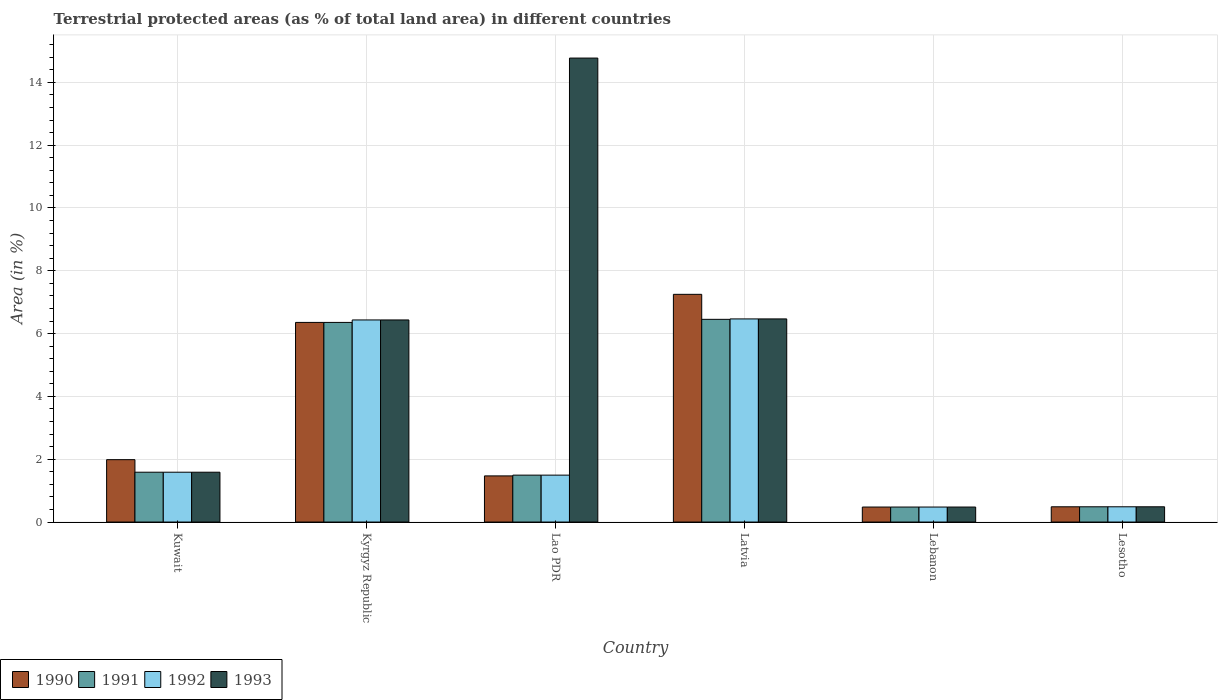How many different coloured bars are there?
Provide a short and direct response. 4. How many bars are there on the 4th tick from the right?
Your answer should be compact. 4. What is the label of the 1st group of bars from the left?
Make the answer very short. Kuwait. In how many cases, is the number of bars for a given country not equal to the number of legend labels?
Your answer should be compact. 0. What is the percentage of terrestrial protected land in 1990 in Lao PDR?
Provide a succinct answer. 1.47. Across all countries, what is the maximum percentage of terrestrial protected land in 1992?
Your response must be concise. 6.47. Across all countries, what is the minimum percentage of terrestrial protected land in 1992?
Ensure brevity in your answer.  0.48. In which country was the percentage of terrestrial protected land in 1993 maximum?
Provide a succinct answer. Lao PDR. In which country was the percentage of terrestrial protected land in 1992 minimum?
Your answer should be compact. Lebanon. What is the total percentage of terrestrial protected land in 1993 in the graph?
Offer a very short reply. 30.23. What is the difference between the percentage of terrestrial protected land in 1993 in Kuwait and that in Kyrgyz Republic?
Make the answer very short. -4.85. What is the difference between the percentage of terrestrial protected land in 1993 in Lesotho and the percentage of terrestrial protected land in 1990 in Kuwait?
Your answer should be very brief. -1.5. What is the average percentage of terrestrial protected land in 1990 per country?
Your response must be concise. 3. What is the difference between the percentage of terrestrial protected land of/in 1990 and percentage of terrestrial protected land of/in 1993 in Kuwait?
Make the answer very short. 0.4. In how many countries, is the percentage of terrestrial protected land in 1992 greater than 14.4 %?
Your answer should be compact. 0. What is the ratio of the percentage of terrestrial protected land in 1990 in Latvia to that in Lebanon?
Ensure brevity in your answer.  15.19. What is the difference between the highest and the second highest percentage of terrestrial protected land in 1992?
Provide a short and direct response. -4.88. What is the difference between the highest and the lowest percentage of terrestrial protected land in 1993?
Keep it short and to the point. 14.3. In how many countries, is the percentage of terrestrial protected land in 1992 greater than the average percentage of terrestrial protected land in 1992 taken over all countries?
Your answer should be very brief. 2. Is it the case that in every country, the sum of the percentage of terrestrial protected land in 1991 and percentage of terrestrial protected land in 1993 is greater than the sum of percentage of terrestrial protected land in 1992 and percentage of terrestrial protected land in 1990?
Provide a short and direct response. No. What does the 2nd bar from the right in Lesotho represents?
Make the answer very short. 1992. Is it the case that in every country, the sum of the percentage of terrestrial protected land in 1992 and percentage of terrestrial protected land in 1993 is greater than the percentage of terrestrial protected land in 1990?
Offer a very short reply. Yes. How many bars are there?
Provide a succinct answer. 24. Are all the bars in the graph horizontal?
Make the answer very short. No. How many countries are there in the graph?
Ensure brevity in your answer.  6. Are the values on the major ticks of Y-axis written in scientific E-notation?
Ensure brevity in your answer.  No. Where does the legend appear in the graph?
Your answer should be compact. Bottom left. How are the legend labels stacked?
Offer a terse response. Horizontal. What is the title of the graph?
Provide a succinct answer. Terrestrial protected areas (as % of total land area) in different countries. What is the label or title of the X-axis?
Ensure brevity in your answer.  Country. What is the label or title of the Y-axis?
Your answer should be compact. Area (in %). What is the Area (in %) of 1990 in Kuwait?
Ensure brevity in your answer.  1.99. What is the Area (in %) of 1991 in Kuwait?
Your answer should be compact. 1.59. What is the Area (in %) in 1992 in Kuwait?
Ensure brevity in your answer.  1.59. What is the Area (in %) in 1993 in Kuwait?
Provide a succinct answer. 1.59. What is the Area (in %) of 1990 in Kyrgyz Republic?
Offer a very short reply. 6.36. What is the Area (in %) of 1991 in Kyrgyz Republic?
Ensure brevity in your answer.  6.36. What is the Area (in %) of 1992 in Kyrgyz Republic?
Offer a terse response. 6.43. What is the Area (in %) in 1993 in Kyrgyz Republic?
Your answer should be very brief. 6.43. What is the Area (in %) in 1990 in Lao PDR?
Offer a terse response. 1.47. What is the Area (in %) in 1991 in Lao PDR?
Ensure brevity in your answer.  1.49. What is the Area (in %) in 1992 in Lao PDR?
Offer a terse response. 1.49. What is the Area (in %) in 1993 in Lao PDR?
Give a very brief answer. 14.77. What is the Area (in %) in 1990 in Latvia?
Offer a very short reply. 7.25. What is the Area (in %) of 1991 in Latvia?
Keep it short and to the point. 6.45. What is the Area (in %) in 1992 in Latvia?
Provide a succinct answer. 6.47. What is the Area (in %) in 1993 in Latvia?
Keep it short and to the point. 6.47. What is the Area (in %) of 1990 in Lebanon?
Make the answer very short. 0.48. What is the Area (in %) in 1991 in Lebanon?
Offer a terse response. 0.48. What is the Area (in %) in 1992 in Lebanon?
Ensure brevity in your answer.  0.48. What is the Area (in %) of 1993 in Lebanon?
Provide a short and direct response. 0.48. What is the Area (in %) in 1990 in Lesotho?
Your answer should be compact. 0.49. What is the Area (in %) of 1991 in Lesotho?
Offer a very short reply. 0.49. What is the Area (in %) of 1992 in Lesotho?
Keep it short and to the point. 0.49. What is the Area (in %) of 1993 in Lesotho?
Ensure brevity in your answer.  0.49. Across all countries, what is the maximum Area (in %) of 1990?
Keep it short and to the point. 7.25. Across all countries, what is the maximum Area (in %) of 1991?
Give a very brief answer. 6.45. Across all countries, what is the maximum Area (in %) in 1992?
Provide a short and direct response. 6.47. Across all countries, what is the maximum Area (in %) of 1993?
Your answer should be compact. 14.77. Across all countries, what is the minimum Area (in %) in 1990?
Your response must be concise. 0.48. Across all countries, what is the minimum Area (in %) in 1991?
Your response must be concise. 0.48. Across all countries, what is the minimum Area (in %) in 1992?
Your answer should be compact. 0.48. Across all countries, what is the minimum Area (in %) in 1993?
Provide a succinct answer. 0.48. What is the total Area (in %) in 1990 in the graph?
Ensure brevity in your answer.  18.03. What is the total Area (in %) of 1991 in the graph?
Keep it short and to the point. 16.85. What is the total Area (in %) in 1992 in the graph?
Keep it short and to the point. 16.95. What is the total Area (in %) in 1993 in the graph?
Provide a succinct answer. 30.23. What is the difference between the Area (in %) in 1990 in Kuwait and that in Kyrgyz Republic?
Your answer should be compact. -4.37. What is the difference between the Area (in %) of 1991 in Kuwait and that in Kyrgyz Republic?
Ensure brevity in your answer.  -4.77. What is the difference between the Area (in %) in 1992 in Kuwait and that in Kyrgyz Republic?
Your response must be concise. -4.85. What is the difference between the Area (in %) in 1993 in Kuwait and that in Kyrgyz Republic?
Your response must be concise. -4.85. What is the difference between the Area (in %) in 1990 in Kuwait and that in Lao PDR?
Ensure brevity in your answer.  0.52. What is the difference between the Area (in %) of 1991 in Kuwait and that in Lao PDR?
Offer a very short reply. 0.09. What is the difference between the Area (in %) of 1992 in Kuwait and that in Lao PDR?
Make the answer very short. 0.09. What is the difference between the Area (in %) of 1993 in Kuwait and that in Lao PDR?
Your answer should be compact. -13.19. What is the difference between the Area (in %) in 1990 in Kuwait and that in Latvia?
Your answer should be compact. -5.26. What is the difference between the Area (in %) of 1991 in Kuwait and that in Latvia?
Your response must be concise. -4.87. What is the difference between the Area (in %) in 1992 in Kuwait and that in Latvia?
Your answer should be compact. -4.88. What is the difference between the Area (in %) of 1993 in Kuwait and that in Latvia?
Give a very brief answer. -4.88. What is the difference between the Area (in %) of 1990 in Kuwait and that in Lebanon?
Give a very brief answer. 1.51. What is the difference between the Area (in %) of 1991 in Kuwait and that in Lebanon?
Ensure brevity in your answer.  1.11. What is the difference between the Area (in %) of 1992 in Kuwait and that in Lebanon?
Your answer should be compact. 1.11. What is the difference between the Area (in %) of 1993 in Kuwait and that in Lebanon?
Give a very brief answer. 1.11. What is the difference between the Area (in %) in 1990 in Kuwait and that in Lesotho?
Your answer should be very brief. 1.5. What is the difference between the Area (in %) of 1991 in Kuwait and that in Lesotho?
Offer a very short reply. 1.1. What is the difference between the Area (in %) in 1992 in Kuwait and that in Lesotho?
Keep it short and to the point. 1.1. What is the difference between the Area (in %) of 1993 in Kuwait and that in Lesotho?
Offer a terse response. 1.1. What is the difference between the Area (in %) of 1990 in Kyrgyz Republic and that in Lao PDR?
Your answer should be compact. 4.89. What is the difference between the Area (in %) of 1991 in Kyrgyz Republic and that in Lao PDR?
Offer a terse response. 4.86. What is the difference between the Area (in %) of 1992 in Kyrgyz Republic and that in Lao PDR?
Your response must be concise. 4.94. What is the difference between the Area (in %) in 1993 in Kyrgyz Republic and that in Lao PDR?
Your answer should be compact. -8.34. What is the difference between the Area (in %) of 1990 in Kyrgyz Republic and that in Latvia?
Provide a short and direct response. -0.89. What is the difference between the Area (in %) in 1991 in Kyrgyz Republic and that in Latvia?
Provide a short and direct response. -0.1. What is the difference between the Area (in %) of 1992 in Kyrgyz Republic and that in Latvia?
Provide a short and direct response. -0.03. What is the difference between the Area (in %) in 1993 in Kyrgyz Republic and that in Latvia?
Provide a succinct answer. -0.03. What is the difference between the Area (in %) in 1990 in Kyrgyz Republic and that in Lebanon?
Keep it short and to the point. 5.88. What is the difference between the Area (in %) of 1991 in Kyrgyz Republic and that in Lebanon?
Ensure brevity in your answer.  5.88. What is the difference between the Area (in %) of 1992 in Kyrgyz Republic and that in Lebanon?
Offer a terse response. 5.96. What is the difference between the Area (in %) in 1993 in Kyrgyz Republic and that in Lebanon?
Offer a very short reply. 5.96. What is the difference between the Area (in %) of 1990 in Kyrgyz Republic and that in Lesotho?
Your answer should be very brief. 5.87. What is the difference between the Area (in %) in 1991 in Kyrgyz Republic and that in Lesotho?
Your answer should be very brief. 5.87. What is the difference between the Area (in %) of 1992 in Kyrgyz Republic and that in Lesotho?
Your answer should be very brief. 5.95. What is the difference between the Area (in %) in 1993 in Kyrgyz Republic and that in Lesotho?
Keep it short and to the point. 5.95. What is the difference between the Area (in %) of 1990 in Lao PDR and that in Latvia?
Provide a short and direct response. -5.78. What is the difference between the Area (in %) in 1991 in Lao PDR and that in Latvia?
Your answer should be very brief. -4.96. What is the difference between the Area (in %) of 1992 in Lao PDR and that in Latvia?
Offer a terse response. -4.97. What is the difference between the Area (in %) in 1993 in Lao PDR and that in Latvia?
Provide a succinct answer. 8.31. What is the difference between the Area (in %) in 1991 in Lao PDR and that in Lebanon?
Your answer should be compact. 1.02. What is the difference between the Area (in %) in 1992 in Lao PDR and that in Lebanon?
Keep it short and to the point. 1.02. What is the difference between the Area (in %) of 1993 in Lao PDR and that in Lebanon?
Ensure brevity in your answer.  14.3. What is the difference between the Area (in %) of 1990 in Lao PDR and that in Lesotho?
Offer a terse response. 0.98. What is the difference between the Area (in %) of 1991 in Lao PDR and that in Lesotho?
Your response must be concise. 1.01. What is the difference between the Area (in %) of 1992 in Lao PDR and that in Lesotho?
Your answer should be compact. 1.01. What is the difference between the Area (in %) in 1993 in Lao PDR and that in Lesotho?
Keep it short and to the point. 14.29. What is the difference between the Area (in %) of 1990 in Latvia and that in Lebanon?
Provide a short and direct response. 6.77. What is the difference between the Area (in %) of 1991 in Latvia and that in Lebanon?
Ensure brevity in your answer.  5.98. What is the difference between the Area (in %) in 1992 in Latvia and that in Lebanon?
Offer a very short reply. 5.99. What is the difference between the Area (in %) of 1993 in Latvia and that in Lebanon?
Your answer should be very brief. 5.99. What is the difference between the Area (in %) of 1990 in Latvia and that in Lesotho?
Keep it short and to the point. 6.77. What is the difference between the Area (in %) of 1991 in Latvia and that in Lesotho?
Ensure brevity in your answer.  5.97. What is the difference between the Area (in %) of 1992 in Latvia and that in Lesotho?
Offer a very short reply. 5.98. What is the difference between the Area (in %) of 1993 in Latvia and that in Lesotho?
Offer a very short reply. 5.98. What is the difference between the Area (in %) of 1990 in Lebanon and that in Lesotho?
Offer a terse response. -0.01. What is the difference between the Area (in %) in 1991 in Lebanon and that in Lesotho?
Your answer should be very brief. -0.01. What is the difference between the Area (in %) of 1992 in Lebanon and that in Lesotho?
Your answer should be very brief. -0.01. What is the difference between the Area (in %) in 1993 in Lebanon and that in Lesotho?
Provide a short and direct response. -0.01. What is the difference between the Area (in %) in 1990 in Kuwait and the Area (in %) in 1991 in Kyrgyz Republic?
Provide a short and direct response. -4.37. What is the difference between the Area (in %) in 1990 in Kuwait and the Area (in %) in 1992 in Kyrgyz Republic?
Provide a short and direct response. -4.45. What is the difference between the Area (in %) in 1990 in Kuwait and the Area (in %) in 1993 in Kyrgyz Republic?
Offer a very short reply. -4.45. What is the difference between the Area (in %) in 1991 in Kuwait and the Area (in %) in 1992 in Kyrgyz Republic?
Make the answer very short. -4.85. What is the difference between the Area (in %) of 1991 in Kuwait and the Area (in %) of 1993 in Kyrgyz Republic?
Your answer should be very brief. -4.85. What is the difference between the Area (in %) in 1992 in Kuwait and the Area (in %) in 1993 in Kyrgyz Republic?
Keep it short and to the point. -4.85. What is the difference between the Area (in %) in 1990 in Kuwait and the Area (in %) in 1991 in Lao PDR?
Your answer should be compact. 0.49. What is the difference between the Area (in %) of 1990 in Kuwait and the Area (in %) of 1992 in Lao PDR?
Your answer should be compact. 0.49. What is the difference between the Area (in %) in 1990 in Kuwait and the Area (in %) in 1993 in Lao PDR?
Keep it short and to the point. -12.79. What is the difference between the Area (in %) of 1991 in Kuwait and the Area (in %) of 1992 in Lao PDR?
Your answer should be compact. 0.09. What is the difference between the Area (in %) in 1991 in Kuwait and the Area (in %) in 1993 in Lao PDR?
Provide a succinct answer. -13.19. What is the difference between the Area (in %) in 1992 in Kuwait and the Area (in %) in 1993 in Lao PDR?
Your answer should be very brief. -13.19. What is the difference between the Area (in %) of 1990 in Kuwait and the Area (in %) of 1991 in Latvia?
Your answer should be very brief. -4.47. What is the difference between the Area (in %) in 1990 in Kuwait and the Area (in %) in 1992 in Latvia?
Give a very brief answer. -4.48. What is the difference between the Area (in %) of 1990 in Kuwait and the Area (in %) of 1993 in Latvia?
Make the answer very short. -4.48. What is the difference between the Area (in %) in 1991 in Kuwait and the Area (in %) in 1992 in Latvia?
Give a very brief answer. -4.88. What is the difference between the Area (in %) of 1991 in Kuwait and the Area (in %) of 1993 in Latvia?
Offer a very short reply. -4.88. What is the difference between the Area (in %) in 1992 in Kuwait and the Area (in %) in 1993 in Latvia?
Provide a short and direct response. -4.88. What is the difference between the Area (in %) of 1990 in Kuwait and the Area (in %) of 1991 in Lebanon?
Offer a terse response. 1.51. What is the difference between the Area (in %) in 1990 in Kuwait and the Area (in %) in 1992 in Lebanon?
Your answer should be compact. 1.51. What is the difference between the Area (in %) in 1990 in Kuwait and the Area (in %) in 1993 in Lebanon?
Provide a succinct answer. 1.51. What is the difference between the Area (in %) in 1991 in Kuwait and the Area (in %) in 1992 in Lebanon?
Your answer should be very brief. 1.11. What is the difference between the Area (in %) of 1991 in Kuwait and the Area (in %) of 1993 in Lebanon?
Your answer should be very brief. 1.11. What is the difference between the Area (in %) in 1992 in Kuwait and the Area (in %) in 1993 in Lebanon?
Ensure brevity in your answer.  1.11. What is the difference between the Area (in %) in 1990 in Kuwait and the Area (in %) in 1991 in Lesotho?
Provide a short and direct response. 1.5. What is the difference between the Area (in %) in 1990 in Kuwait and the Area (in %) in 1992 in Lesotho?
Offer a very short reply. 1.5. What is the difference between the Area (in %) of 1990 in Kuwait and the Area (in %) of 1993 in Lesotho?
Your answer should be very brief. 1.5. What is the difference between the Area (in %) of 1991 in Kuwait and the Area (in %) of 1992 in Lesotho?
Your answer should be very brief. 1.1. What is the difference between the Area (in %) in 1991 in Kuwait and the Area (in %) in 1993 in Lesotho?
Make the answer very short. 1.1. What is the difference between the Area (in %) in 1992 in Kuwait and the Area (in %) in 1993 in Lesotho?
Keep it short and to the point. 1.1. What is the difference between the Area (in %) of 1990 in Kyrgyz Republic and the Area (in %) of 1991 in Lao PDR?
Offer a very short reply. 4.86. What is the difference between the Area (in %) in 1990 in Kyrgyz Republic and the Area (in %) in 1992 in Lao PDR?
Your answer should be compact. 4.86. What is the difference between the Area (in %) in 1990 in Kyrgyz Republic and the Area (in %) in 1993 in Lao PDR?
Offer a terse response. -8.42. What is the difference between the Area (in %) of 1991 in Kyrgyz Republic and the Area (in %) of 1992 in Lao PDR?
Make the answer very short. 4.86. What is the difference between the Area (in %) in 1991 in Kyrgyz Republic and the Area (in %) in 1993 in Lao PDR?
Offer a terse response. -8.42. What is the difference between the Area (in %) in 1992 in Kyrgyz Republic and the Area (in %) in 1993 in Lao PDR?
Keep it short and to the point. -8.34. What is the difference between the Area (in %) in 1990 in Kyrgyz Republic and the Area (in %) in 1991 in Latvia?
Offer a very short reply. -0.1. What is the difference between the Area (in %) in 1990 in Kyrgyz Republic and the Area (in %) in 1992 in Latvia?
Your answer should be compact. -0.11. What is the difference between the Area (in %) in 1990 in Kyrgyz Republic and the Area (in %) in 1993 in Latvia?
Keep it short and to the point. -0.11. What is the difference between the Area (in %) of 1991 in Kyrgyz Republic and the Area (in %) of 1992 in Latvia?
Provide a short and direct response. -0.11. What is the difference between the Area (in %) of 1991 in Kyrgyz Republic and the Area (in %) of 1993 in Latvia?
Keep it short and to the point. -0.11. What is the difference between the Area (in %) of 1992 in Kyrgyz Republic and the Area (in %) of 1993 in Latvia?
Your answer should be very brief. -0.03. What is the difference between the Area (in %) of 1990 in Kyrgyz Republic and the Area (in %) of 1991 in Lebanon?
Provide a short and direct response. 5.88. What is the difference between the Area (in %) in 1990 in Kyrgyz Republic and the Area (in %) in 1992 in Lebanon?
Provide a short and direct response. 5.88. What is the difference between the Area (in %) in 1990 in Kyrgyz Republic and the Area (in %) in 1993 in Lebanon?
Offer a terse response. 5.88. What is the difference between the Area (in %) of 1991 in Kyrgyz Republic and the Area (in %) of 1992 in Lebanon?
Your answer should be very brief. 5.88. What is the difference between the Area (in %) of 1991 in Kyrgyz Republic and the Area (in %) of 1993 in Lebanon?
Your response must be concise. 5.88. What is the difference between the Area (in %) of 1992 in Kyrgyz Republic and the Area (in %) of 1993 in Lebanon?
Give a very brief answer. 5.96. What is the difference between the Area (in %) in 1990 in Kyrgyz Republic and the Area (in %) in 1991 in Lesotho?
Make the answer very short. 5.87. What is the difference between the Area (in %) in 1990 in Kyrgyz Republic and the Area (in %) in 1992 in Lesotho?
Give a very brief answer. 5.87. What is the difference between the Area (in %) in 1990 in Kyrgyz Republic and the Area (in %) in 1993 in Lesotho?
Your answer should be compact. 5.87. What is the difference between the Area (in %) in 1991 in Kyrgyz Republic and the Area (in %) in 1992 in Lesotho?
Ensure brevity in your answer.  5.87. What is the difference between the Area (in %) in 1991 in Kyrgyz Republic and the Area (in %) in 1993 in Lesotho?
Keep it short and to the point. 5.87. What is the difference between the Area (in %) of 1992 in Kyrgyz Republic and the Area (in %) of 1993 in Lesotho?
Offer a very short reply. 5.95. What is the difference between the Area (in %) in 1990 in Lao PDR and the Area (in %) in 1991 in Latvia?
Your answer should be compact. -4.99. What is the difference between the Area (in %) of 1990 in Lao PDR and the Area (in %) of 1992 in Latvia?
Give a very brief answer. -5. What is the difference between the Area (in %) in 1990 in Lao PDR and the Area (in %) in 1993 in Latvia?
Provide a short and direct response. -5. What is the difference between the Area (in %) of 1991 in Lao PDR and the Area (in %) of 1992 in Latvia?
Provide a succinct answer. -4.97. What is the difference between the Area (in %) of 1991 in Lao PDR and the Area (in %) of 1993 in Latvia?
Your answer should be compact. -4.97. What is the difference between the Area (in %) in 1992 in Lao PDR and the Area (in %) in 1993 in Latvia?
Your answer should be very brief. -4.97. What is the difference between the Area (in %) in 1990 in Lao PDR and the Area (in %) in 1991 in Lebanon?
Provide a short and direct response. 0.99. What is the difference between the Area (in %) of 1990 in Lao PDR and the Area (in %) of 1992 in Lebanon?
Make the answer very short. 0.99. What is the difference between the Area (in %) of 1991 in Lao PDR and the Area (in %) of 1992 in Lebanon?
Your response must be concise. 1.02. What is the difference between the Area (in %) of 1991 in Lao PDR and the Area (in %) of 1993 in Lebanon?
Your answer should be very brief. 1.02. What is the difference between the Area (in %) in 1992 in Lao PDR and the Area (in %) in 1993 in Lebanon?
Your response must be concise. 1.02. What is the difference between the Area (in %) of 1990 in Lao PDR and the Area (in %) of 1991 in Lesotho?
Your answer should be very brief. 0.98. What is the difference between the Area (in %) in 1990 in Lao PDR and the Area (in %) in 1992 in Lesotho?
Provide a succinct answer. 0.98. What is the difference between the Area (in %) in 1990 in Lao PDR and the Area (in %) in 1993 in Lesotho?
Provide a short and direct response. 0.98. What is the difference between the Area (in %) in 1991 in Lao PDR and the Area (in %) in 1992 in Lesotho?
Provide a succinct answer. 1.01. What is the difference between the Area (in %) of 1991 in Lao PDR and the Area (in %) of 1993 in Lesotho?
Your response must be concise. 1.01. What is the difference between the Area (in %) of 1992 in Lao PDR and the Area (in %) of 1993 in Lesotho?
Make the answer very short. 1.01. What is the difference between the Area (in %) in 1990 in Latvia and the Area (in %) in 1991 in Lebanon?
Ensure brevity in your answer.  6.77. What is the difference between the Area (in %) in 1990 in Latvia and the Area (in %) in 1992 in Lebanon?
Make the answer very short. 6.77. What is the difference between the Area (in %) of 1990 in Latvia and the Area (in %) of 1993 in Lebanon?
Provide a short and direct response. 6.77. What is the difference between the Area (in %) of 1991 in Latvia and the Area (in %) of 1992 in Lebanon?
Give a very brief answer. 5.98. What is the difference between the Area (in %) of 1991 in Latvia and the Area (in %) of 1993 in Lebanon?
Give a very brief answer. 5.98. What is the difference between the Area (in %) in 1992 in Latvia and the Area (in %) in 1993 in Lebanon?
Your response must be concise. 5.99. What is the difference between the Area (in %) of 1990 in Latvia and the Area (in %) of 1991 in Lesotho?
Offer a very short reply. 6.77. What is the difference between the Area (in %) of 1990 in Latvia and the Area (in %) of 1992 in Lesotho?
Make the answer very short. 6.77. What is the difference between the Area (in %) of 1990 in Latvia and the Area (in %) of 1993 in Lesotho?
Your answer should be very brief. 6.77. What is the difference between the Area (in %) in 1991 in Latvia and the Area (in %) in 1992 in Lesotho?
Your answer should be compact. 5.97. What is the difference between the Area (in %) of 1991 in Latvia and the Area (in %) of 1993 in Lesotho?
Offer a terse response. 5.97. What is the difference between the Area (in %) of 1992 in Latvia and the Area (in %) of 1993 in Lesotho?
Ensure brevity in your answer.  5.98. What is the difference between the Area (in %) of 1990 in Lebanon and the Area (in %) of 1991 in Lesotho?
Give a very brief answer. -0.01. What is the difference between the Area (in %) of 1990 in Lebanon and the Area (in %) of 1992 in Lesotho?
Ensure brevity in your answer.  -0.01. What is the difference between the Area (in %) in 1990 in Lebanon and the Area (in %) in 1993 in Lesotho?
Offer a very short reply. -0.01. What is the difference between the Area (in %) of 1991 in Lebanon and the Area (in %) of 1992 in Lesotho?
Make the answer very short. -0.01. What is the difference between the Area (in %) in 1991 in Lebanon and the Area (in %) in 1993 in Lesotho?
Make the answer very short. -0.01. What is the difference between the Area (in %) in 1992 in Lebanon and the Area (in %) in 1993 in Lesotho?
Give a very brief answer. -0.01. What is the average Area (in %) of 1990 per country?
Offer a very short reply. 3. What is the average Area (in %) of 1991 per country?
Make the answer very short. 2.81. What is the average Area (in %) in 1992 per country?
Provide a short and direct response. 2.82. What is the average Area (in %) in 1993 per country?
Your response must be concise. 5.04. What is the difference between the Area (in %) of 1990 and Area (in %) of 1991 in Kuwait?
Your answer should be compact. 0.4. What is the difference between the Area (in %) of 1990 and Area (in %) of 1992 in Kuwait?
Provide a succinct answer. 0.4. What is the difference between the Area (in %) of 1990 and Area (in %) of 1993 in Kuwait?
Your answer should be compact. 0.4. What is the difference between the Area (in %) of 1991 and Area (in %) of 1992 in Kuwait?
Keep it short and to the point. 0. What is the difference between the Area (in %) in 1992 and Area (in %) in 1993 in Kuwait?
Ensure brevity in your answer.  0. What is the difference between the Area (in %) of 1990 and Area (in %) of 1991 in Kyrgyz Republic?
Your answer should be compact. 0. What is the difference between the Area (in %) of 1990 and Area (in %) of 1992 in Kyrgyz Republic?
Your answer should be very brief. -0.08. What is the difference between the Area (in %) of 1990 and Area (in %) of 1993 in Kyrgyz Republic?
Offer a very short reply. -0.08. What is the difference between the Area (in %) in 1991 and Area (in %) in 1992 in Kyrgyz Republic?
Offer a terse response. -0.08. What is the difference between the Area (in %) of 1991 and Area (in %) of 1993 in Kyrgyz Republic?
Ensure brevity in your answer.  -0.08. What is the difference between the Area (in %) of 1992 and Area (in %) of 1993 in Kyrgyz Republic?
Make the answer very short. 0. What is the difference between the Area (in %) in 1990 and Area (in %) in 1991 in Lao PDR?
Make the answer very short. -0.02. What is the difference between the Area (in %) of 1990 and Area (in %) of 1992 in Lao PDR?
Ensure brevity in your answer.  -0.02. What is the difference between the Area (in %) of 1990 and Area (in %) of 1993 in Lao PDR?
Offer a terse response. -13.3. What is the difference between the Area (in %) of 1991 and Area (in %) of 1992 in Lao PDR?
Offer a very short reply. 0. What is the difference between the Area (in %) in 1991 and Area (in %) in 1993 in Lao PDR?
Your answer should be compact. -13.28. What is the difference between the Area (in %) of 1992 and Area (in %) of 1993 in Lao PDR?
Your answer should be very brief. -13.28. What is the difference between the Area (in %) of 1990 and Area (in %) of 1991 in Latvia?
Provide a short and direct response. 0.8. What is the difference between the Area (in %) of 1990 and Area (in %) of 1992 in Latvia?
Make the answer very short. 0.78. What is the difference between the Area (in %) of 1990 and Area (in %) of 1993 in Latvia?
Your answer should be very brief. 0.78. What is the difference between the Area (in %) of 1991 and Area (in %) of 1992 in Latvia?
Offer a terse response. -0.01. What is the difference between the Area (in %) in 1991 and Area (in %) in 1993 in Latvia?
Keep it short and to the point. -0.01. What is the difference between the Area (in %) in 1992 and Area (in %) in 1993 in Latvia?
Make the answer very short. 0. What is the difference between the Area (in %) of 1990 and Area (in %) of 1992 in Lebanon?
Give a very brief answer. 0. What is the difference between the Area (in %) in 1990 and Area (in %) in 1993 in Lesotho?
Make the answer very short. 0. What is the difference between the Area (in %) in 1991 and Area (in %) in 1992 in Lesotho?
Make the answer very short. 0. What is the ratio of the Area (in %) of 1990 in Kuwait to that in Kyrgyz Republic?
Your response must be concise. 0.31. What is the ratio of the Area (in %) in 1991 in Kuwait to that in Kyrgyz Republic?
Your answer should be very brief. 0.25. What is the ratio of the Area (in %) in 1992 in Kuwait to that in Kyrgyz Republic?
Your response must be concise. 0.25. What is the ratio of the Area (in %) of 1993 in Kuwait to that in Kyrgyz Republic?
Provide a succinct answer. 0.25. What is the ratio of the Area (in %) of 1990 in Kuwait to that in Lao PDR?
Keep it short and to the point. 1.35. What is the ratio of the Area (in %) in 1991 in Kuwait to that in Lao PDR?
Make the answer very short. 1.06. What is the ratio of the Area (in %) of 1992 in Kuwait to that in Lao PDR?
Provide a succinct answer. 1.06. What is the ratio of the Area (in %) of 1993 in Kuwait to that in Lao PDR?
Offer a very short reply. 0.11. What is the ratio of the Area (in %) of 1990 in Kuwait to that in Latvia?
Offer a very short reply. 0.27. What is the ratio of the Area (in %) of 1991 in Kuwait to that in Latvia?
Offer a terse response. 0.25. What is the ratio of the Area (in %) in 1992 in Kuwait to that in Latvia?
Ensure brevity in your answer.  0.25. What is the ratio of the Area (in %) in 1993 in Kuwait to that in Latvia?
Keep it short and to the point. 0.25. What is the ratio of the Area (in %) of 1990 in Kuwait to that in Lebanon?
Keep it short and to the point. 4.16. What is the ratio of the Area (in %) in 1991 in Kuwait to that in Lebanon?
Offer a very short reply. 3.32. What is the ratio of the Area (in %) of 1992 in Kuwait to that in Lebanon?
Ensure brevity in your answer.  3.32. What is the ratio of the Area (in %) in 1993 in Kuwait to that in Lebanon?
Your answer should be very brief. 3.32. What is the ratio of the Area (in %) in 1990 in Kuwait to that in Lesotho?
Keep it short and to the point. 4.09. What is the ratio of the Area (in %) in 1991 in Kuwait to that in Lesotho?
Your answer should be compact. 3.27. What is the ratio of the Area (in %) in 1992 in Kuwait to that in Lesotho?
Your response must be concise. 3.27. What is the ratio of the Area (in %) of 1993 in Kuwait to that in Lesotho?
Your response must be concise. 3.27. What is the ratio of the Area (in %) in 1990 in Kyrgyz Republic to that in Lao PDR?
Provide a succinct answer. 4.33. What is the ratio of the Area (in %) in 1991 in Kyrgyz Republic to that in Lao PDR?
Offer a terse response. 4.26. What is the ratio of the Area (in %) in 1992 in Kyrgyz Republic to that in Lao PDR?
Provide a succinct answer. 4.31. What is the ratio of the Area (in %) of 1993 in Kyrgyz Republic to that in Lao PDR?
Provide a short and direct response. 0.44. What is the ratio of the Area (in %) in 1990 in Kyrgyz Republic to that in Latvia?
Make the answer very short. 0.88. What is the ratio of the Area (in %) in 1991 in Kyrgyz Republic to that in Latvia?
Make the answer very short. 0.98. What is the ratio of the Area (in %) of 1992 in Kyrgyz Republic to that in Latvia?
Keep it short and to the point. 0.99. What is the ratio of the Area (in %) of 1990 in Kyrgyz Republic to that in Lebanon?
Give a very brief answer. 13.31. What is the ratio of the Area (in %) in 1991 in Kyrgyz Republic to that in Lebanon?
Provide a short and direct response. 13.32. What is the ratio of the Area (in %) in 1992 in Kyrgyz Republic to that in Lebanon?
Offer a very short reply. 13.48. What is the ratio of the Area (in %) of 1993 in Kyrgyz Republic to that in Lebanon?
Your answer should be compact. 13.48. What is the ratio of the Area (in %) in 1990 in Kyrgyz Republic to that in Lesotho?
Your answer should be very brief. 13.1. What is the ratio of the Area (in %) of 1991 in Kyrgyz Republic to that in Lesotho?
Give a very brief answer. 13.1. What is the ratio of the Area (in %) in 1992 in Kyrgyz Republic to that in Lesotho?
Offer a terse response. 13.26. What is the ratio of the Area (in %) of 1993 in Kyrgyz Republic to that in Lesotho?
Your answer should be compact. 13.26. What is the ratio of the Area (in %) in 1990 in Lao PDR to that in Latvia?
Keep it short and to the point. 0.2. What is the ratio of the Area (in %) in 1991 in Lao PDR to that in Latvia?
Provide a short and direct response. 0.23. What is the ratio of the Area (in %) in 1992 in Lao PDR to that in Latvia?
Your answer should be very brief. 0.23. What is the ratio of the Area (in %) of 1993 in Lao PDR to that in Latvia?
Offer a terse response. 2.28. What is the ratio of the Area (in %) of 1990 in Lao PDR to that in Lebanon?
Make the answer very short. 3.08. What is the ratio of the Area (in %) in 1991 in Lao PDR to that in Lebanon?
Make the answer very short. 3.13. What is the ratio of the Area (in %) in 1992 in Lao PDR to that in Lebanon?
Provide a succinct answer. 3.13. What is the ratio of the Area (in %) in 1993 in Lao PDR to that in Lebanon?
Make the answer very short. 30.95. What is the ratio of the Area (in %) of 1990 in Lao PDR to that in Lesotho?
Ensure brevity in your answer.  3.03. What is the ratio of the Area (in %) of 1991 in Lao PDR to that in Lesotho?
Offer a terse response. 3.08. What is the ratio of the Area (in %) of 1992 in Lao PDR to that in Lesotho?
Give a very brief answer. 3.08. What is the ratio of the Area (in %) in 1993 in Lao PDR to that in Lesotho?
Your response must be concise. 30.44. What is the ratio of the Area (in %) in 1990 in Latvia to that in Lebanon?
Ensure brevity in your answer.  15.19. What is the ratio of the Area (in %) of 1991 in Latvia to that in Lebanon?
Offer a very short reply. 13.52. What is the ratio of the Area (in %) in 1992 in Latvia to that in Lebanon?
Your response must be concise. 13.55. What is the ratio of the Area (in %) in 1993 in Latvia to that in Lebanon?
Keep it short and to the point. 13.55. What is the ratio of the Area (in %) in 1990 in Latvia to that in Lesotho?
Your response must be concise. 14.94. What is the ratio of the Area (in %) in 1991 in Latvia to that in Lesotho?
Your answer should be compact. 13.3. What is the ratio of the Area (in %) in 1992 in Latvia to that in Lesotho?
Your response must be concise. 13.33. What is the ratio of the Area (in %) of 1993 in Latvia to that in Lesotho?
Give a very brief answer. 13.33. What is the ratio of the Area (in %) of 1990 in Lebanon to that in Lesotho?
Provide a succinct answer. 0.98. What is the ratio of the Area (in %) in 1991 in Lebanon to that in Lesotho?
Keep it short and to the point. 0.98. What is the ratio of the Area (in %) in 1992 in Lebanon to that in Lesotho?
Offer a very short reply. 0.98. What is the ratio of the Area (in %) in 1993 in Lebanon to that in Lesotho?
Provide a succinct answer. 0.98. What is the difference between the highest and the second highest Area (in %) of 1990?
Provide a succinct answer. 0.89. What is the difference between the highest and the second highest Area (in %) in 1991?
Give a very brief answer. 0.1. What is the difference between the highest and the second highest Area (in %) of 1992?
Keep it short and to the point. 0.03. What is the difference between the highest and the second highest Area (in %) of 1993?
Your response must be concise. 8.31. What is the difference between the highest and the lowest Area (in %) of 1990?
Give a very brief answer. 6.77. What is the difference between the highest and the lowest Area (in %) of 1991?
Your answer should be compact. 5.98. What is the difference between the highest and the lowest Area (in %) in 1992?
Provide a succinct answer. 5.99. What is the difference between the highest and the lowest Area (in %) of 1993?
Provide a succinct answer. 14.3. 